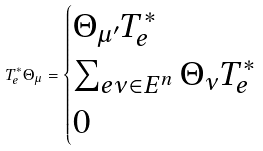<formula> <loc_0><loc_0><loc_500><loc_500>T ^ { * } _ { e } \Theta _ { \mu } = \begin{cases} \Theta _ { \mu ^ { \prime } } T ^ { * } _ { e } & \\ \sum _ { e \nu \in E ^ { n } } \Theta _ { \nu } T ^ { * } _ { e } & \\ 0 & \end{cases}</formula> 